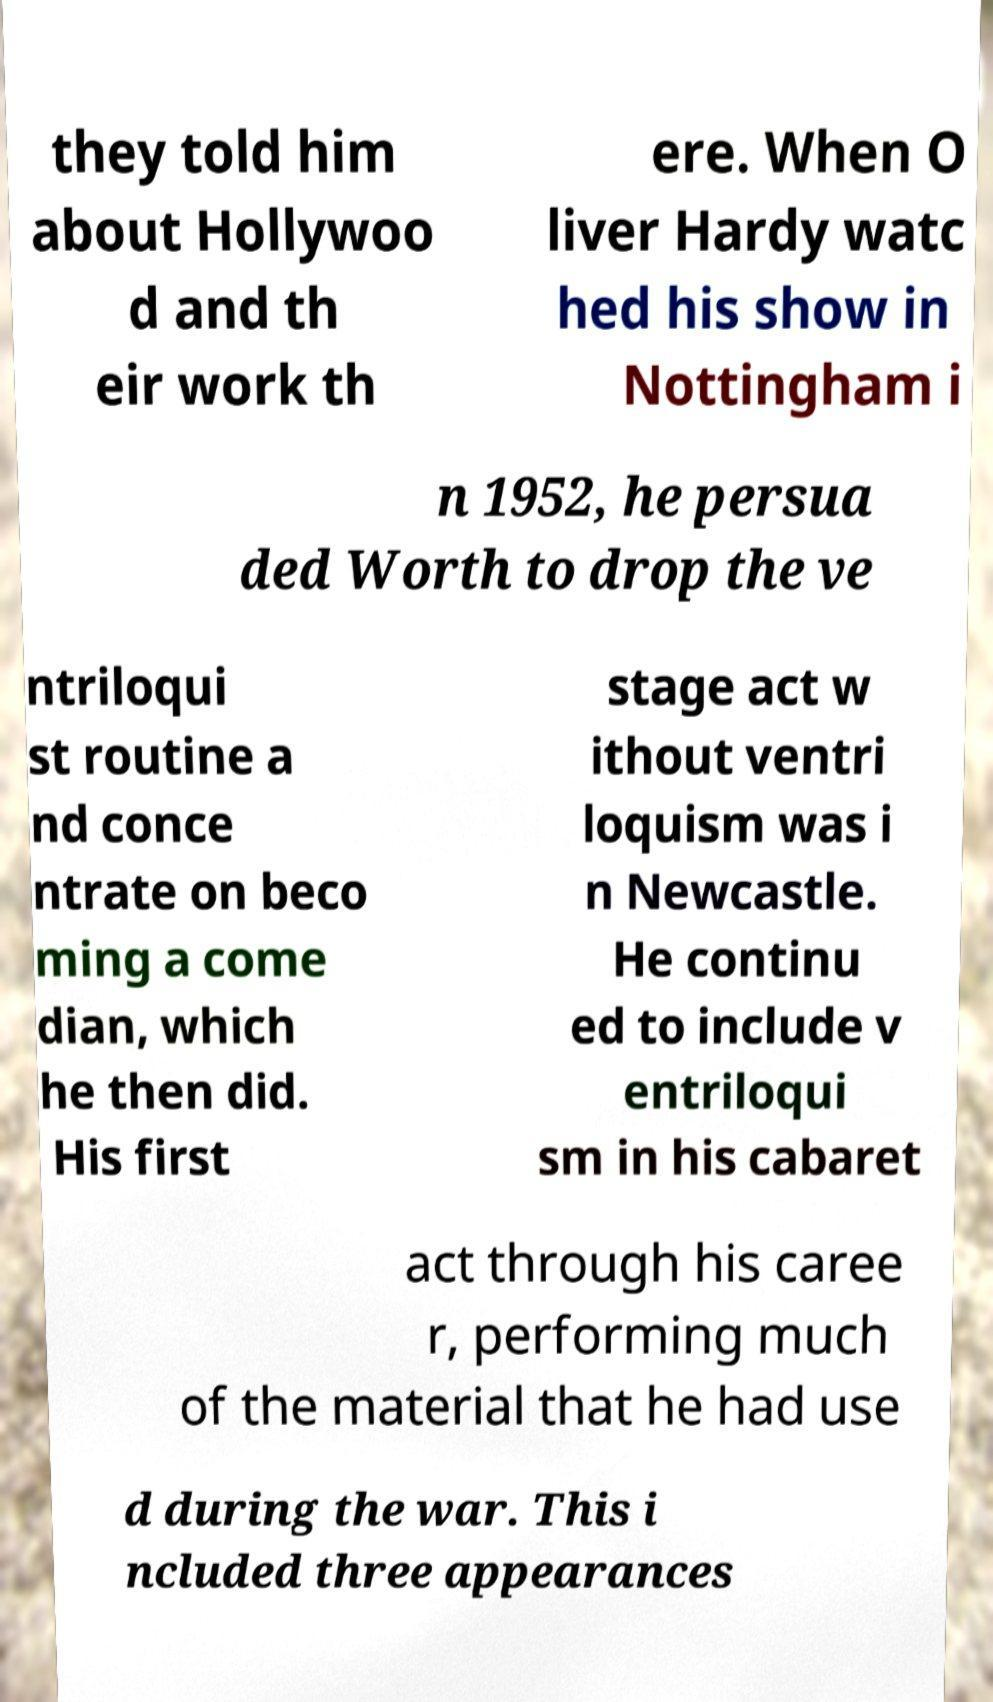There's text embedded in this image that I need extracted. Can you transcribe it verbatim? they told him about Hollywoo d and th eir work th ere. When O liver Hardy watc hed his show in Nottingham i n 1952, he persua ded Worth to drop the ve ntriloqui st routine a nd conce ntrate on beco ming a come dian, which he then did. His first stage act w ithout ventri loquism was i n Newcastle. He continu ed to include v entriloqui sm in his cabaret act through his caree r, performing much of the material that he had use d during the war. This i ncluded three appearances 